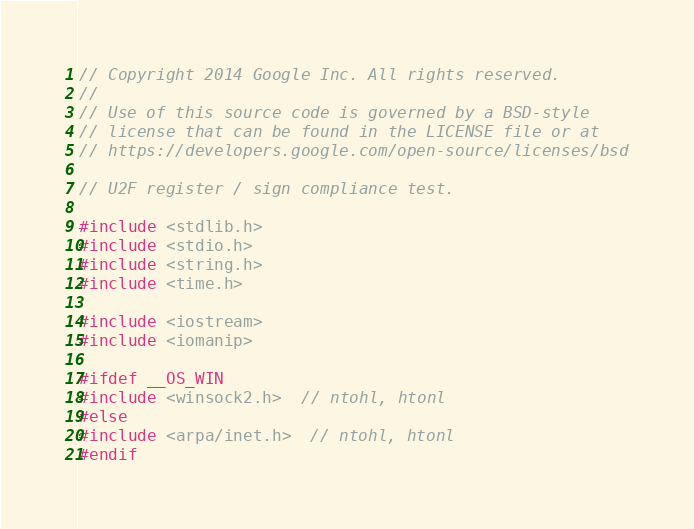Convert code to text. <code><loc_0><loc_0><loc_500><loc_500><_C++_>// Copyright 2014 Google Inc. All rights reserved.
//
// Use of this source code is governed by a BSD-style
// license that can be found in the LICENSE file or at
// https://developers.google.com/open-source/licenses/bsd

// U2F register / sign compliance test.

#include <stdlib.h>
#include <stdio.h>
#include <string.h>
#include <time.h>

#include <iostream>
#include <iomanip>

#ifdef __OS_WIN
#include <winsock2.h>  // ntohl, htonl
#else
#include <arpa/inet.h>  // ntohl, htonl
#endif
</code> 